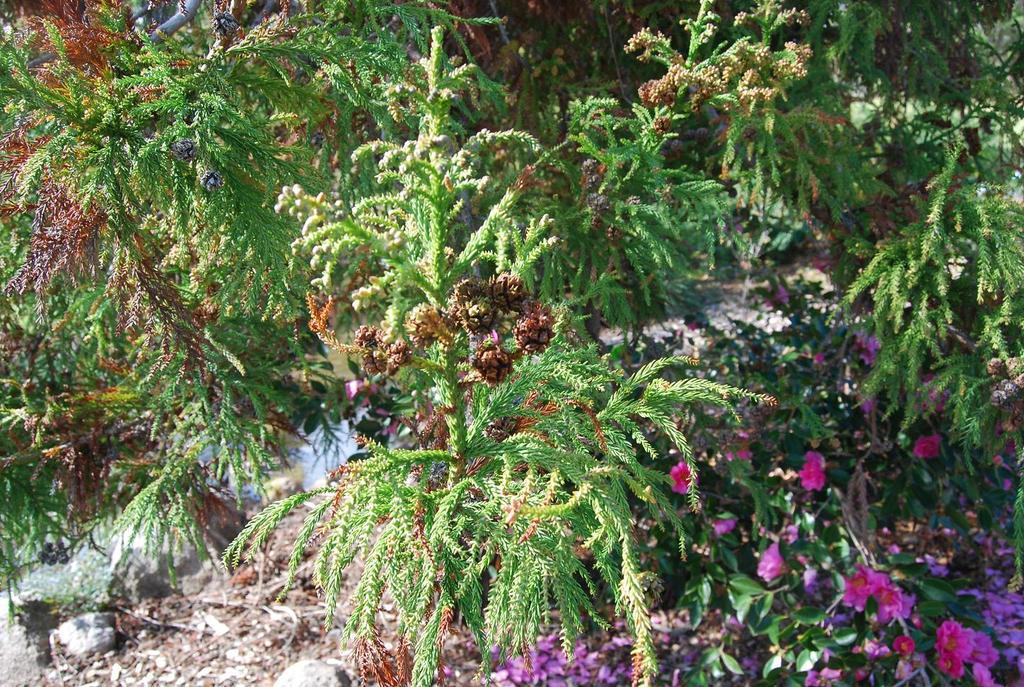What type of objects can be seen on the ground in the image? There are stones and sticks on the ground in the image. What type of flora is present in the image? There are flowers in the image. What can be seen in the background of the image? There are plants visible in the background of the image. What rule does the sister enforce in the image? There is no mention of a sister or any rules in the image. 